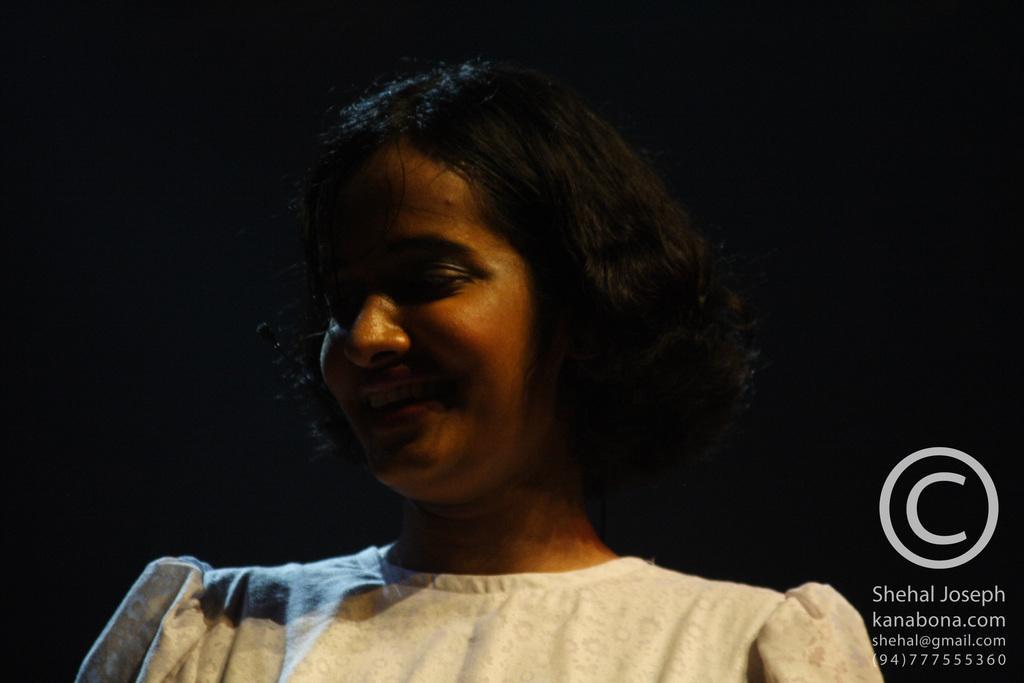Can you describe this image briefly? In this picture we can see one girl. 